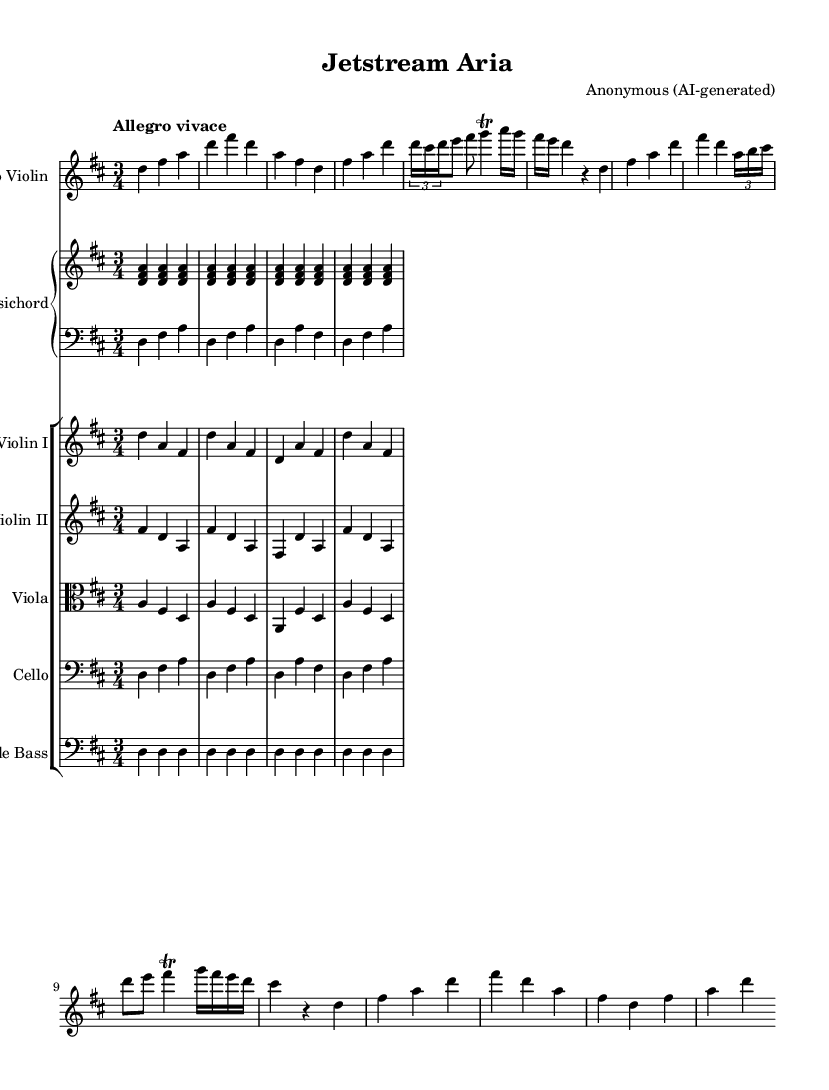What is the key signature of this music? The key signature is D major, which has two sharps, F# and C#. This can be determined from the beginning of the sheet music where the key is stated.
Answer: D major What is the time signature of this music? The time signature is 3/4, indicated at the beginning of the score. This means there are three beats in each measure and the quarter note gets one beat.
Answer: 3/4 What is the tempo marking for this piece? The tempo marking is "Allegro vivace," which suggests a fast and lively pace. This is explicitly noted at the start of the sheet music.
Answer: Allegro vivace How many sections are in the violin solo part? There are three sections in the violin solo part: the Ritornello, Solo Section 1, and Solo Section 2, followed by the Final Ritornello. These are identified in the music by their labels and distinguished rhythmic patterns.
Answer: Three Which instrument plays the bass line? The instrument playing the bass line is the Double Bass, as indicated by the final staff labeled "Double Bass" in the score.
Answer: Double Bass What compositional technique is employed with the tuplet in the solo section? The tuplet appearing in the solo section uses a 3 against 2 rhythm, which introduces an interesting rhythmic complexity. It can be spotted in the notation where three notes are played in the time usually taken by two.
Answer: 3 against 2 What style of music is this piece an example of? This piece is an example of Baroque music, characterized by its ornamentation, expressive melodies, and the use of concertos. This can be inferred from the compositional techniques and instrumental texture typical of the Baroque era.
Answer: Baroque 